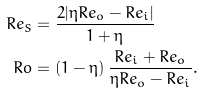Convert formula to latex. <formula><loc_0><loc_0><loc_500><loc_500>R e _ { S } & = \frac { 2 | \eta R e _ { o } - R e _ { i } | } { 1 + \eta } \\ R o & = ( 1 - \eta ) \, \frac { R e _ { i } + R e _ { o } } { \eta R e _ { o } - R e _ { i } } .</formula> 